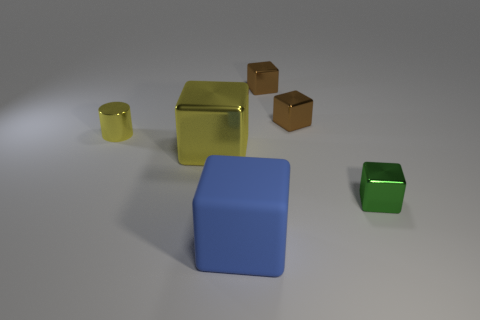Subtract all big blue rubber cubes. How many cubes are left? 4 Add 4 large blue shiny objects. How many objects exist? 10 Subtract all brown blocks. How many blocks are left? 3 Subtract all cylinders. How many objects are left? 5 Subtract all large gray objects. Subtract all tiny cubes. How many objects are left? 3 Add 6 yellow cylinders. How many yellow cylinders are left? 7 Add 3 cubes. How many cubes exist? 8 Subtract 1 green blocks. How many objects are left? 5 Subtract 1 cylinders. How many cylinders are left? 0 Subtract all brown cylinders. Subtract all gray balls. How many cylinders are left? 1 